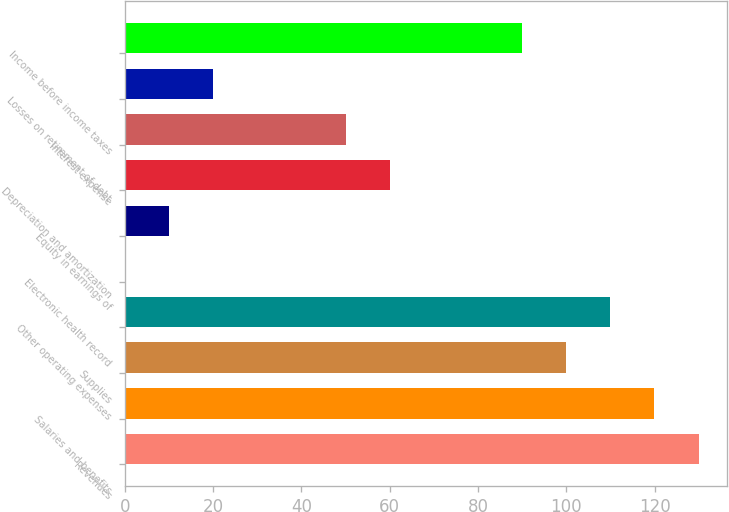Convert chart to OTSL. <chart><loc_0><loc_0><loc_500><loc_500><bar_chart><fcel>Revenues<fcel>Salaries and benefits<fcel>Supplies<fcel>Other operating expenses<fcel>Electronic health record<fcel>Equity in earnings of<fcel>Depreciation and amortization<fcel>Interest expense<fcel>Losses on retirement of debt<fcel>Income before income taxes<nl><fcel>129.97<fcel>119.98<fcel>100<fcel>109.99<fcel>0.1<fcel>10.09<fcel>60.04<fcel>50.05<fcel>20.08<fcel>90.01<nl></chart> 